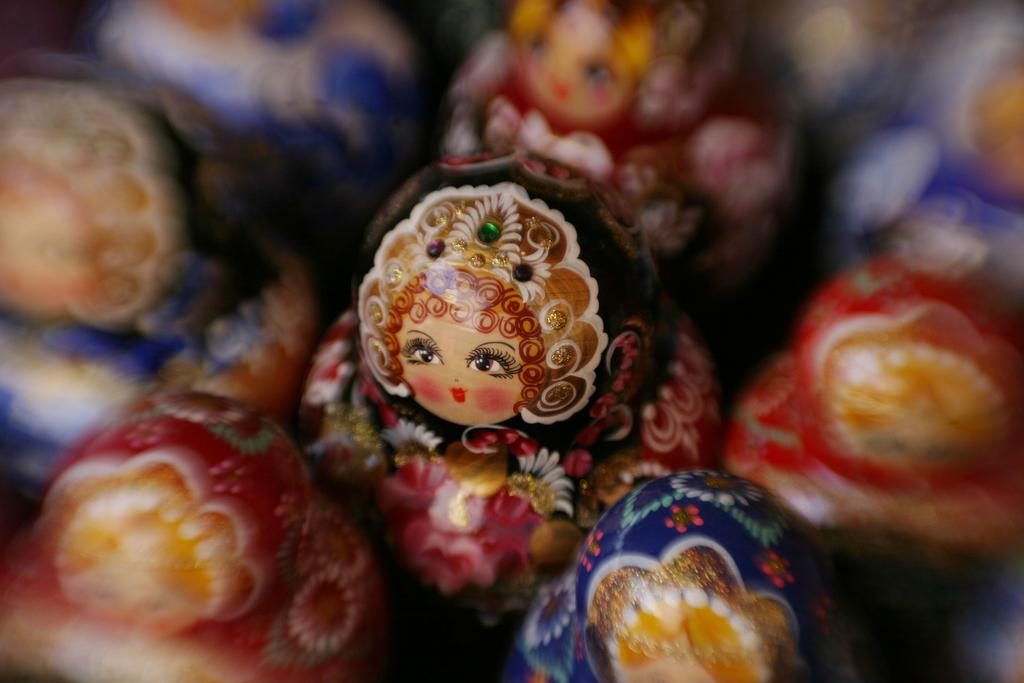What type of dolls are in the image? There are wooden dolls in the image. What colors are the wooden dolls? A: The wooden dolls are in pink, red, and blue colors. Can you describe the background of the image? The background of the image is blurred. What type of agreement is being signed by the tomatoes in the image? There are no tomatoes present in the image, and therefore no agreement can be signed by them. 